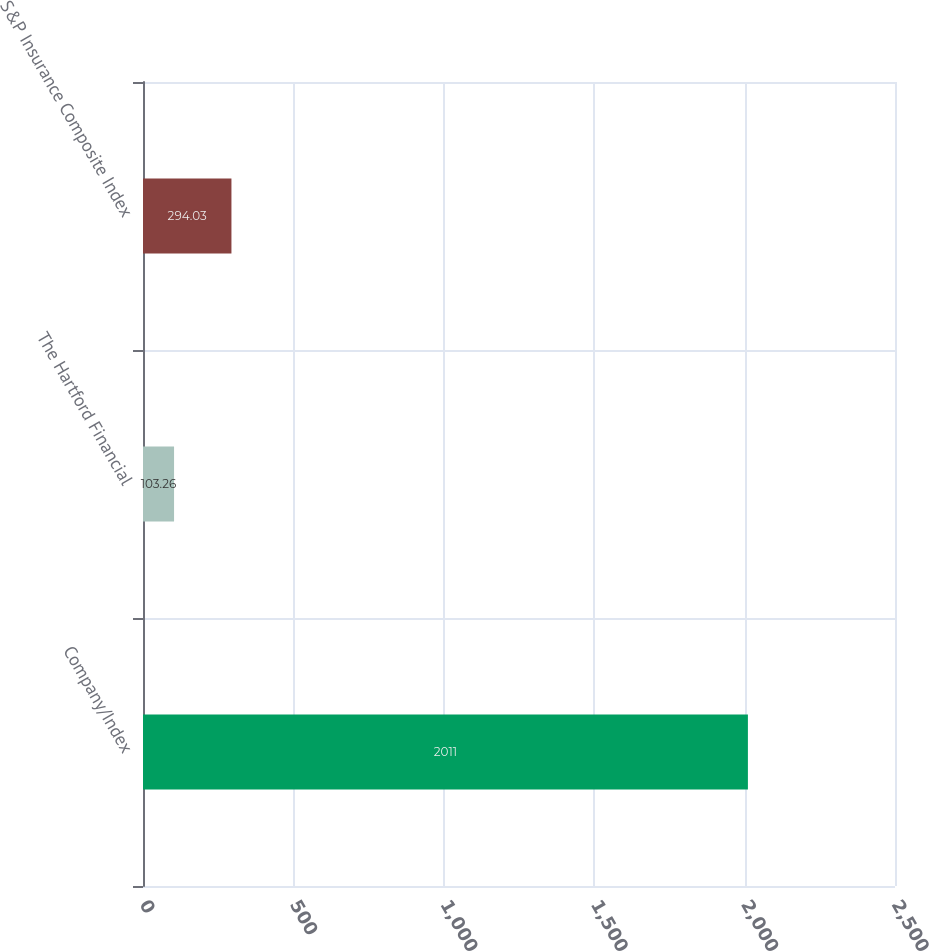Convert chart. <chart><loc_0><loc_0><loc_500><loc_500><bar_chart><fcel>Company/Index<fcel>The Hartford Financial<fcel>S&P Insurance Composite Index<nl><fcel>2011<fcel>103.26<fcel>294.03<nl></chart> 